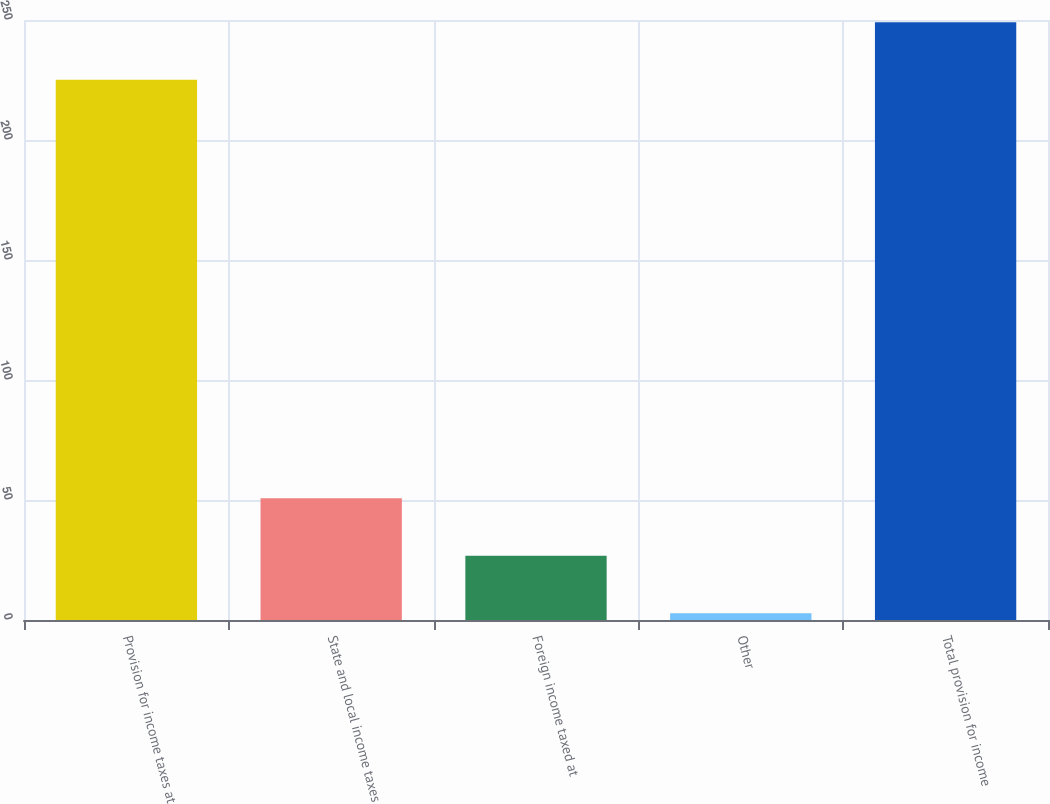<chart> <loc_0><loc_0><loc_500><loc_500><bar_chart><fcel>Provision for income taxes at<fcel>State and local income taxes<fcel>Foreign income taxed at<fcel>Other<fcel>Total provision for income<nl><fcel>225.1<fcel>50.72<fcel>26.76<fcel>2.8<fcel>249.06<nl></chart> 